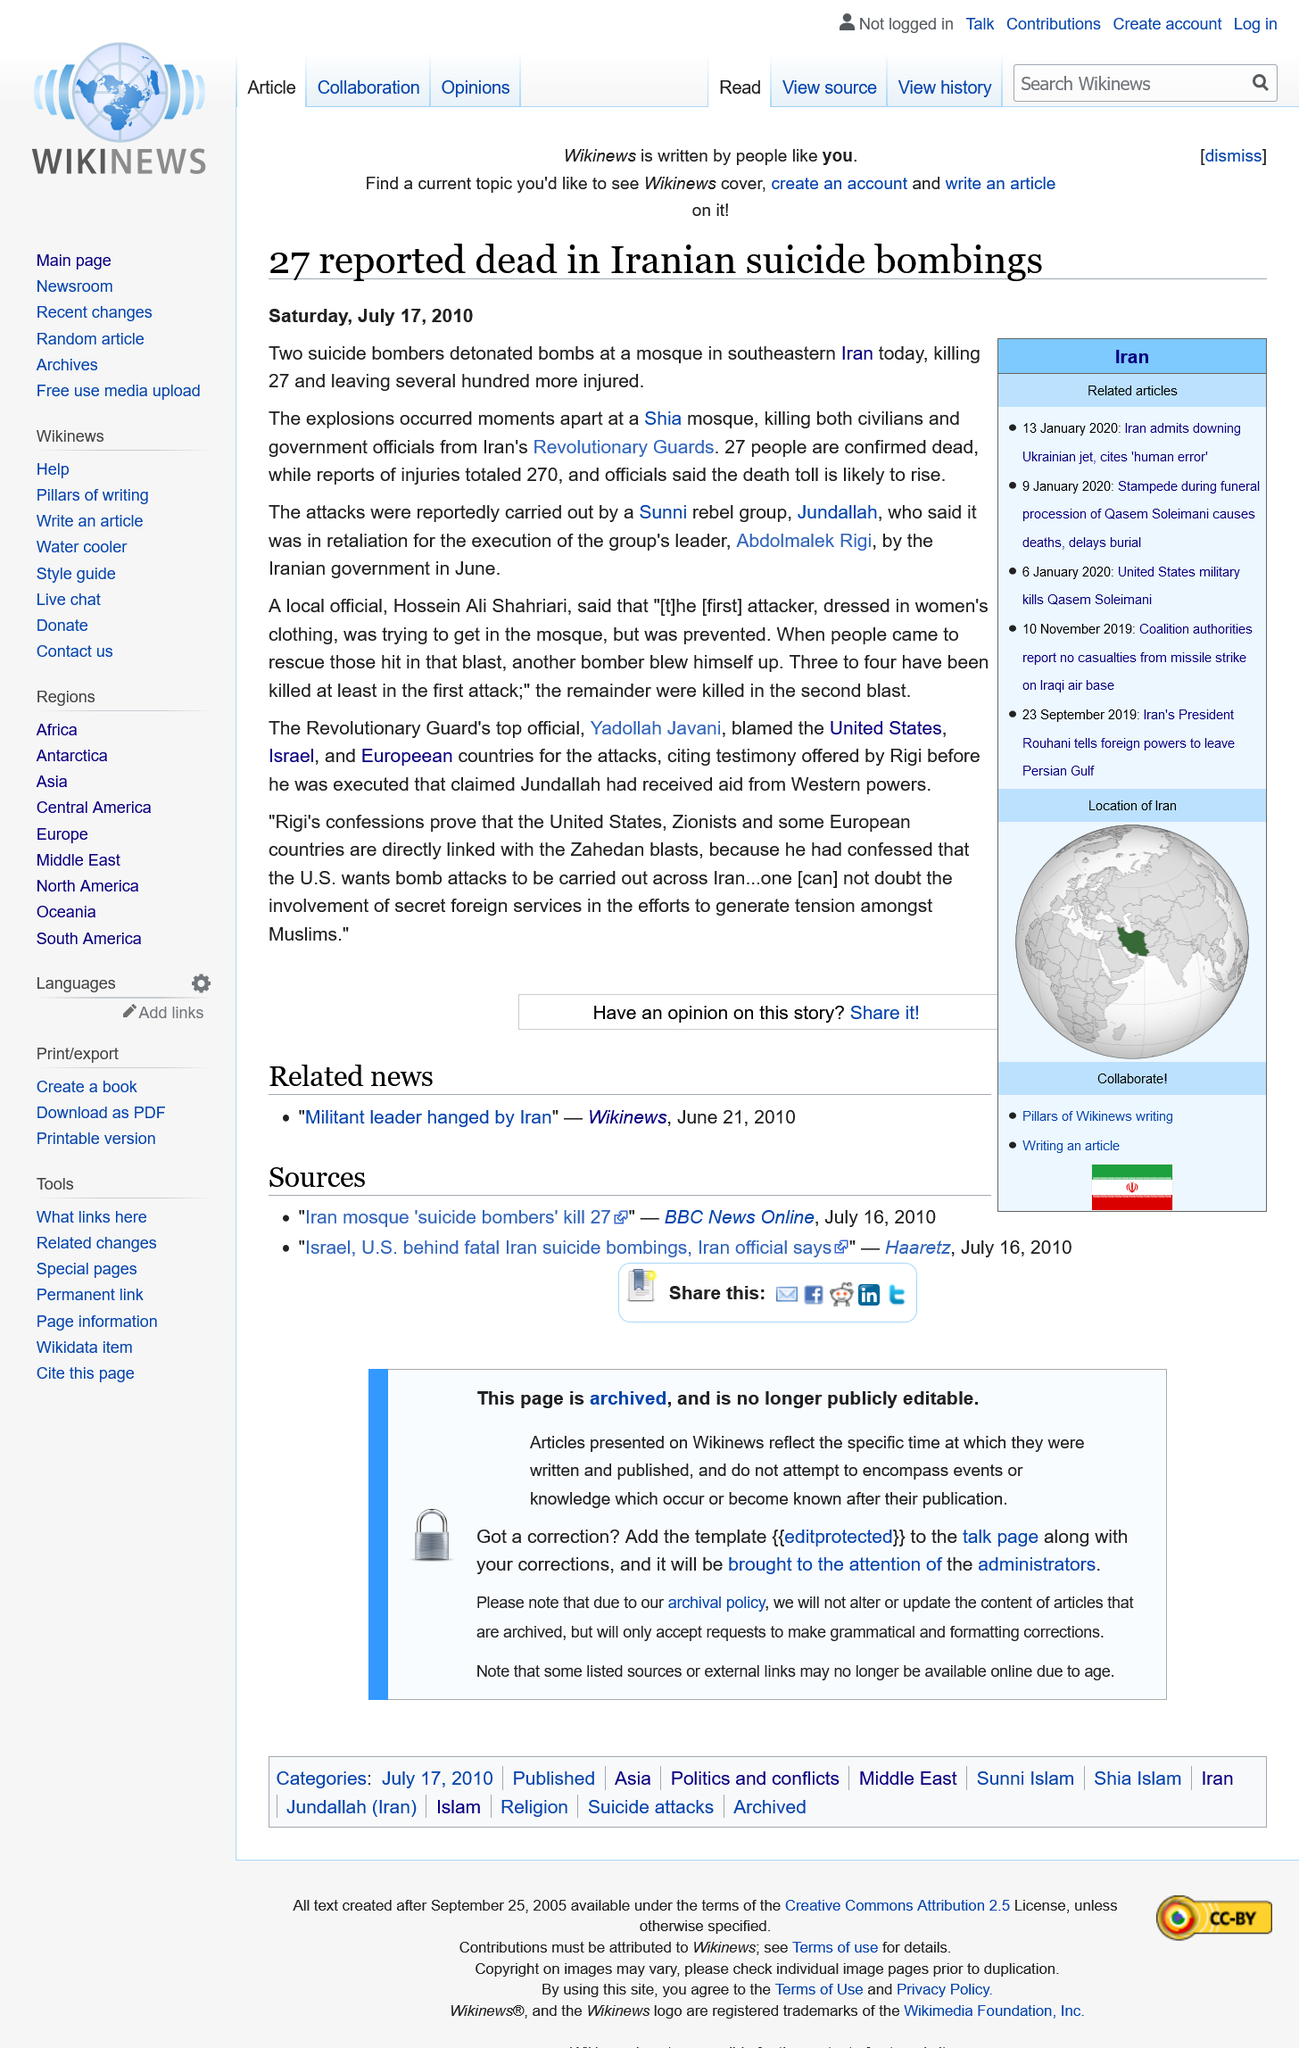Highlight a few significant elements in this photo. The reported death toll from the incident, in which two suicide bombers were responsible for the loss of 27 lives, is 27 people. On Saturday, July 17th, 2010, two suicide bombers detonated bombs at a Shia mosque, resulting in multiple casualties and damage to the structure. On Saturday, July 17th, 2010, a suicide bomber attack was carried out by a Sunni rebel group called Jundallah. 